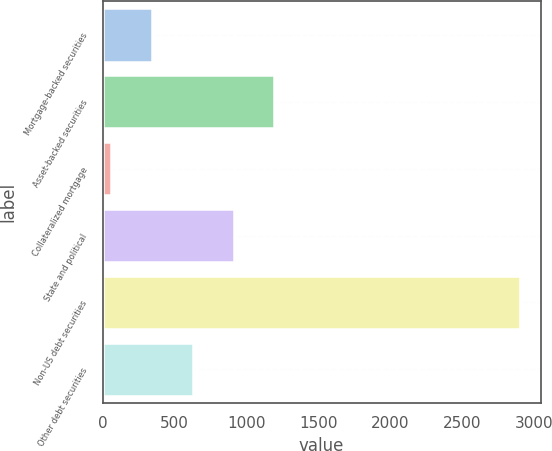Convert chart to OTSL. <chart><loc_0><loc_0><loc_500><loc_500><bar_chart><fcel>Mortgage-backed securities<fcel>Asset-backed securities<fcel>Collateralized mortgage<fcel>State and political<fcel>Non-US debt securities<fcel>Other debt securities<nl><fcel>342.1<fcel>1194.4<fcel>58<fcel>910.3<fcel>2899<fcel>626.2<nl></chart> 